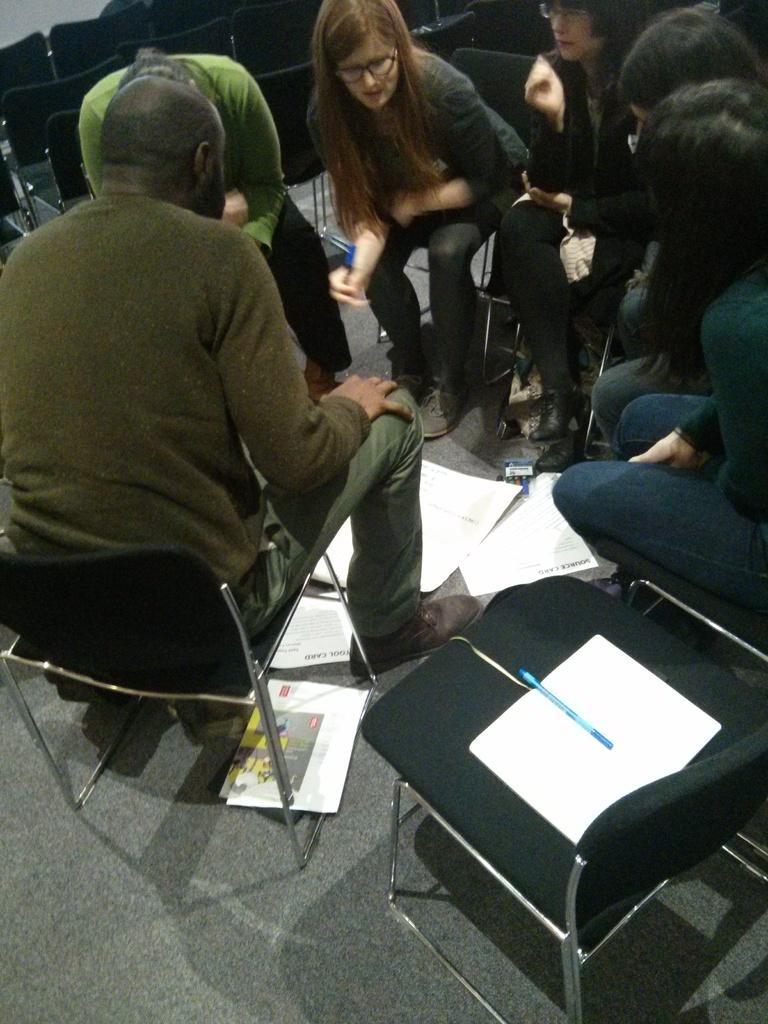Could you give a brief overview of what you see in this image? This picture is clicked inside a room. Here, we can see six people sitting on chair and discussing something and in the right bottom, we see a chair on which book and pen is placed. We can see paper on the floor and behind these people, we see many empty chairs. 